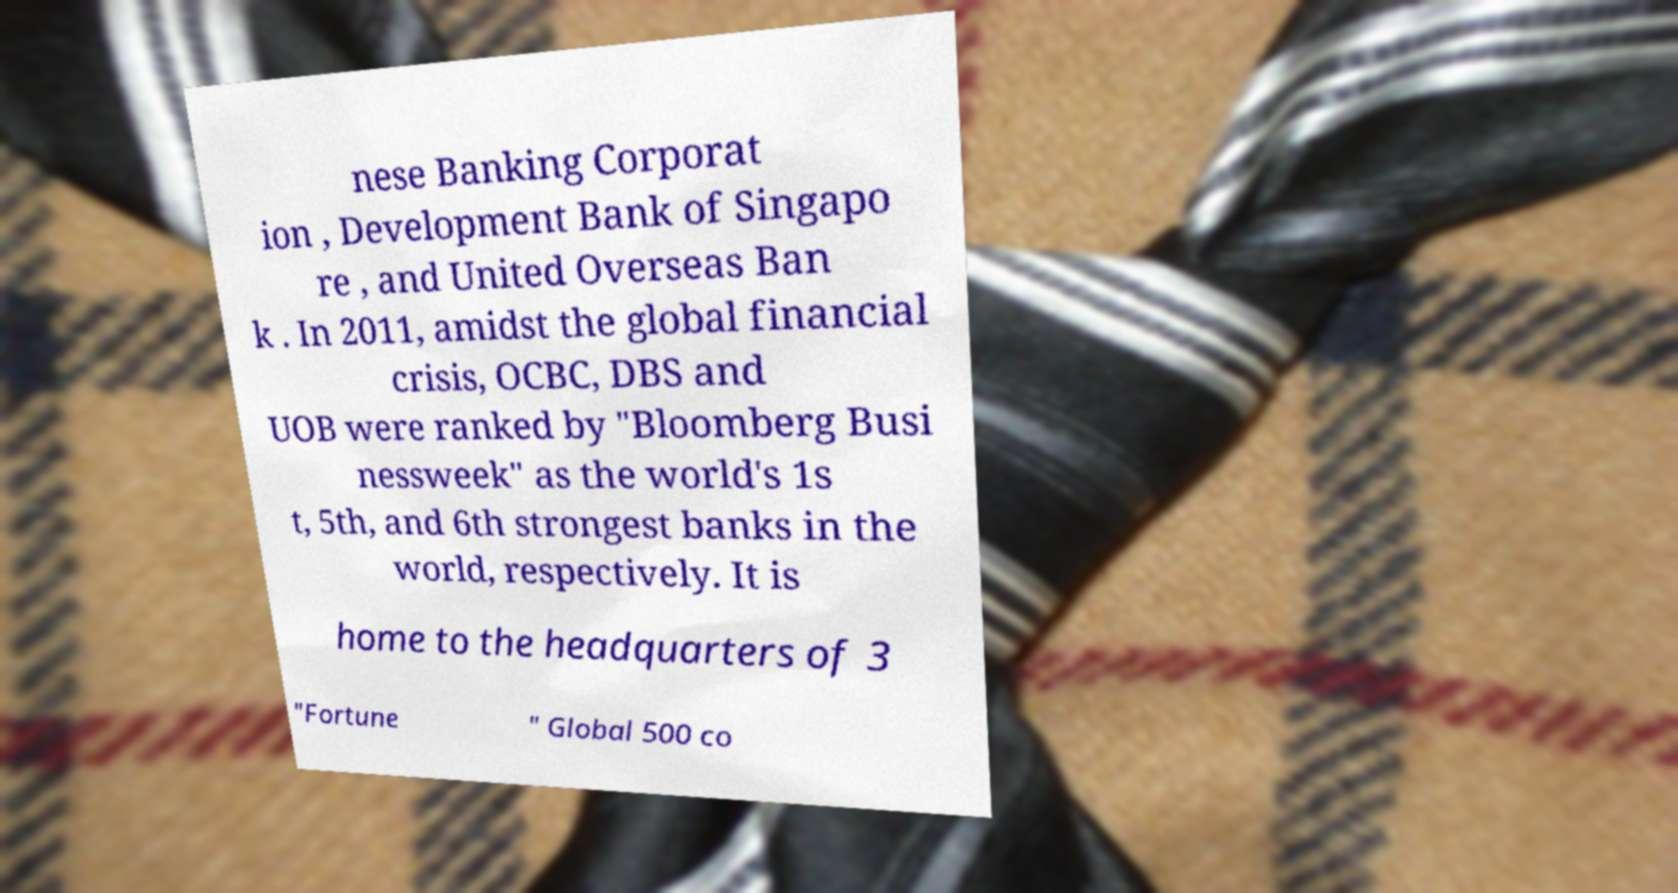Please read and relay the text visible in this image. What does it say? nese Banking Corporat ion , Development Bank of Singapo re , and United Overseas Ban k . In 2011, amidst the global financial crisis, OCBC, DBS and UOB were ranked by "Bloomberg Busi nessweek" as the world's 1s t, 5th, and 6th strongest banks in the world, respectively. It is home to the headquarters of 3 "Fortune " Global 500 co 